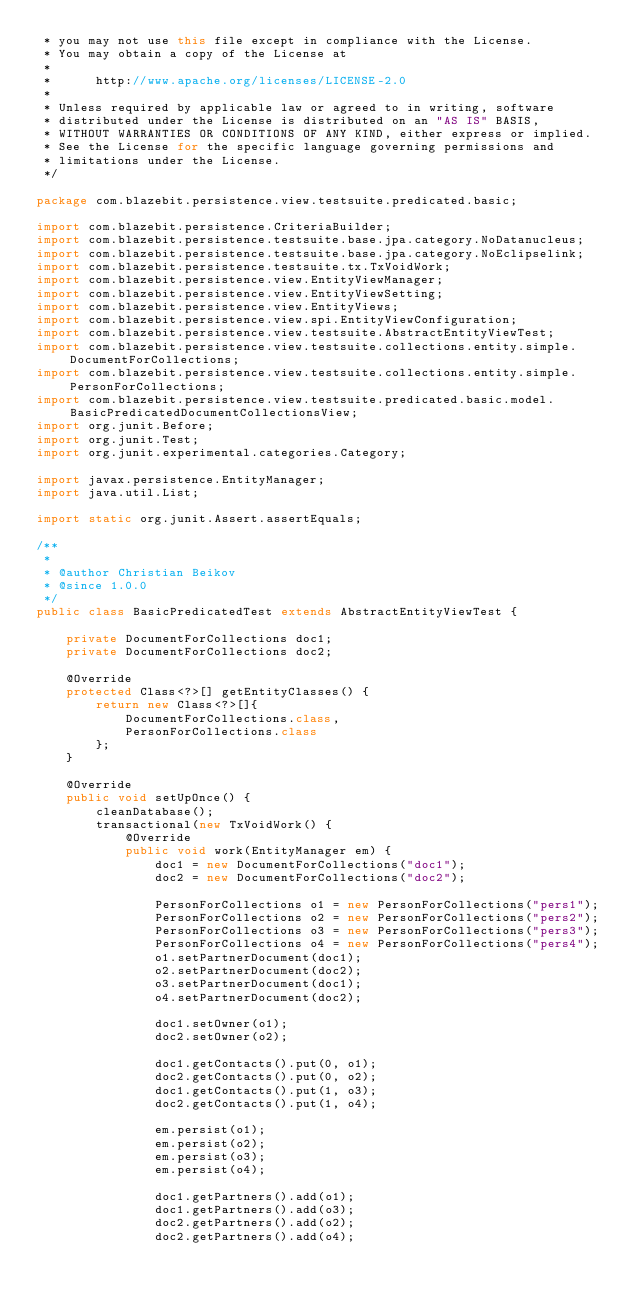<code> <loc_0><loc_0><loc_500><loc_500><_Java_> * you may not use this file except in compliance with the License.
 * You may obtain a copy of the License at
 *
 *      http://www.apache.org/licenses/LICENSE-2.0
 *
 * Unless required by applicable law or agreed to in writing, software
 * distributed under the License is distributed on an "AS IS" BASIS,
 * WITHOUT WARRANTIES OR CONDITIONS OF ANY KIND, either express or implied.
 * See the License for the specific language governing permissions and
 * limitations under the License.
 */

package com.blazebit.persistence.view.testsuite.predicated.basic;

import com.blazebit.persistence.CriteriaBuilder;
import com.blazebit.persistence.testsuite.base.jpa.category.NoDatanucleus;
import com.blazebit.persistence.testsuite.base.jpa.category.NoEclipselink;
import com.blazebit.persistence.testsuite.tx.TxVoidWork;
import com.blazebit.persistence.view.EntityViewManager;
import com.blazebit.persistence.view.EntityViewSetting;
import com.blazebit.persistence.view.EntityViews;
import com.blazebit.persistence.view.spi.EntityViewConfiguration;
import com.blazebit.persistence.view.testsuite.AbstractEntityViewTest;
import com.blazebit.persistence.view.testsuite.collections.entity.simple.DocumentForCollections;
import com.blazebit.persistence.view.testsuite.collections.entity.simple.PersonForCollections;
import com.blazebit.persistence.view.testsuite.predicated.basic.model.BasicPredicatedDocumentCollectionsView;
import org.junit.Before;
import org.junit.Test;
import org.junit.experimental.categories.Category;

import javax.persistence.EntityManager;
import java.util.List;

import static org.junit.Assert.assertEquals;

/**
 *
 * @author Christian Beikov
 * @since 1.0.0
 */
public class BasicPredicatedTest extends AbstractEntityViewTest {

    private DocumentForCollections doc1;
    private DocumentForCollections doc2;

    @Override
    protected Class<?>[] getEntityClasses() {
        return new Class<?>[]{
            DocumentForCollections.class,
            PersonForCollections.class
        };
    }

    @Override
    public void setUpOnce() {
        cleanDatabase();
        transactional(new TxVoidWork() {
            @Override
            public void work(EntityManager em) {
                doc1 = new DocumentForCollections("doc1");
                doc2 = new DocumentForCollections("doc2");

                PersonForCollections o1 = new PersonForCollections("pers1");
                PersonForCollections o2 = new PersonForCollections("pers2");
                PersonForCollections o3 = new PersonForCollections("pers3");
                PersonForCollections o4 = new PersonForCollections("pers4");
                o1.setPartnerDocument(doc1);
                o2.setPartnerDocument(doc2);
                o3.setPartnerDocument(doc1);
                o4.setPartnerDocument(doc2);

                doc1.setOwner(o1);
                doc2.setOwner(o2);

                doc1.getContacts().put(0, o1);
                doc2.getContacts().put(0, o2);
                doc1.getContacts().put(1, o3);
                doc2.getContacts().put(1, o4);

                em.persist(o1);
                em.persist(o2);
                em.persist(o3);
                em.persist(o4);

                doc1.getPartners().add(o1);
                doc1.getPartners().add(o3);
                doc2.getPartners().add(o2);
                doc2.getPartners().add(o4);
</code> 